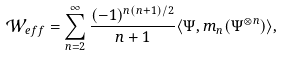Convert formula to latex. <formula><loc_0><loc_0><loc_500><loc_500>\mathcal { W } _ { e f f } & = \sum _ { n = 2 } ^ { \infty } \frac { ( - 1 ) ^ { n ( n + 1 ) / 2 } } { n + 1 } \langle \Psi , m _ { n } ( \Psi ^ { \otimes n } ) \rangle ,</formula> 